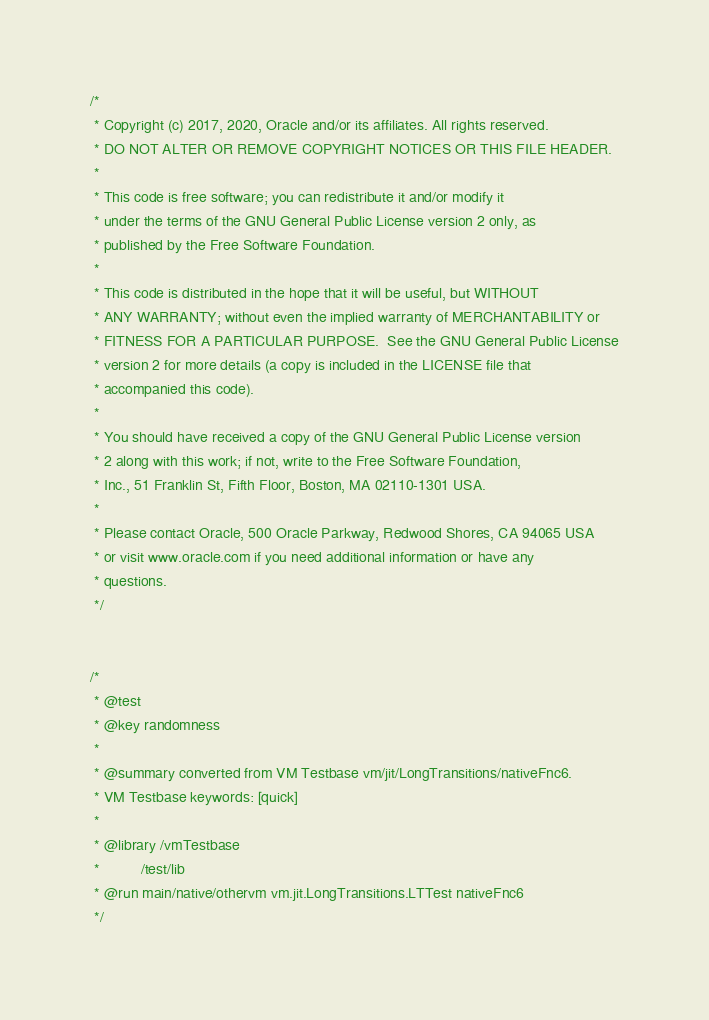Convert code to text. <code><loc_0><loc_0><loc_500><loc_500><_Java_>/*
 * Copyright (c) 2017, 2020, Oracle and/or its affiliates. All rights reserved.
 * DO NOT ALTER OR REMOVE COPYRIGHT NOTICES OR THIS FILE HEADER.
 *
 * This code is free software; you can redistribute it and/or modify it
 * under the terms of the GNU General Public License version 2 only, as
 * published by the Free Software Foundation.
 *
 * This code is distributed in the hope that it will be useful, but WITHOUT
 * ANY WARRANTY; without even the implied warranty of MERCHANTABILITY or
 * FITNESS FOR A PARTICULAR PURPOSE.  See the GNU General Public License
 * version 2 for more details (a copy is included in the LICENSE file that
 * accompanied this code).
 *
 * You should have received a copy of the GNU General Public License version
 * 2 along with this work; if not, write to the Free Software Foundation,
 * Inc., 51 Franklin St, Fifth Floor, Boston, MA 02110-1301 USA.
 *
 * Please contact Oracle, 500 Oracle Parkway, Redwood Shores, CA 94065 USA
 * or visit www.oracle.com if you need additional information or have any
 * questions.
 */


/*
 * @test
 * @key randomness
 *
 * @summary converted from VM Testbase vm/jit/LongTransitions/nativeFnc6.
 * VM Testbase keywords: [quick]
 *
 * @library /vmTestbase
 *          /test/lib
 * @run main/native/othervm vm.jit.LongTransitions.LTTest nativeFnc6
 */

</code> 